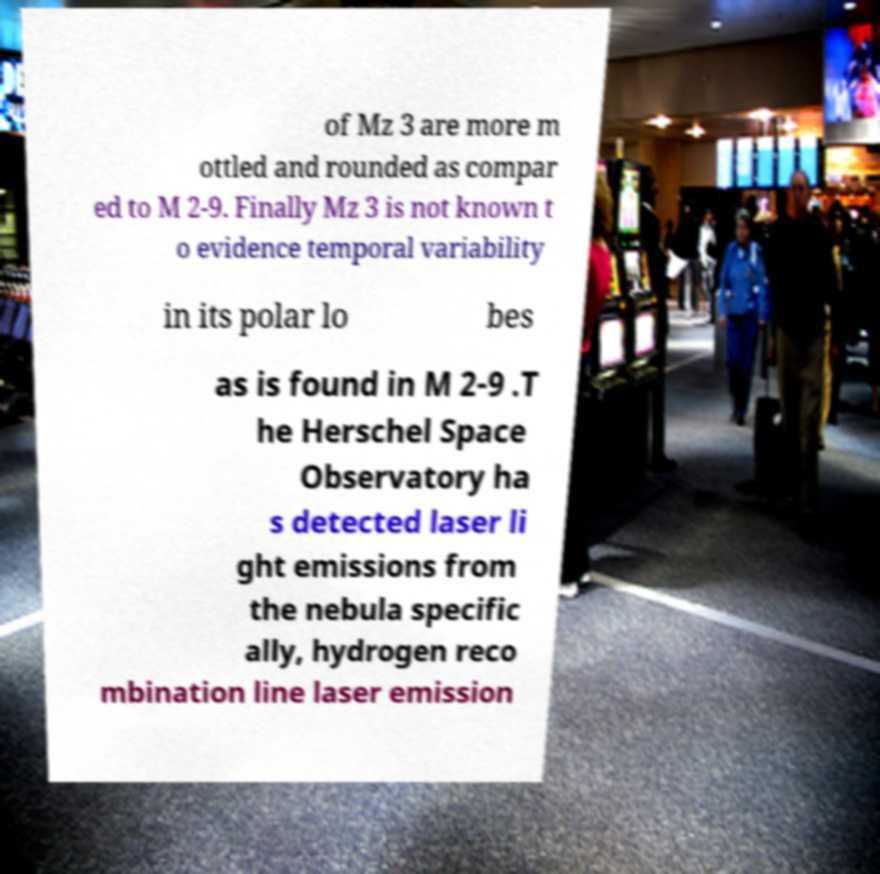What messages or text are displayed in this image? I need them in a readable, typed format. of Mz 3 are more m ottled and rounded as compar ed to M 2-9. Finally Mz 3 is not known t o evidence temporal variability in its polar lo bes as is found in M 2-9 .T he Herschel Space Observatory ha s detected laser li ght emissions from the nebula specific ally, hydrogen reco mbination line laser emission 